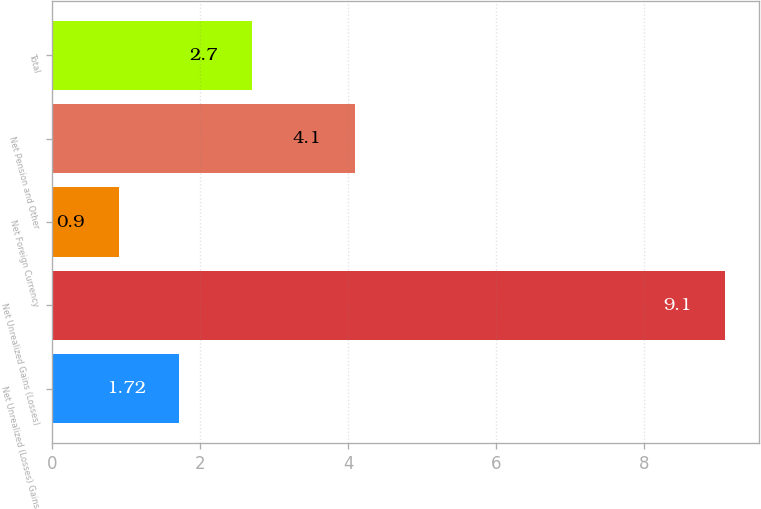<chart> <loc_0><loc_0><loc_500><loc_500><bar_chart><fcel>Net Unrealized (Losses) Gains<fcel>Net Unrealized Gains (Losses)<fcel>Net Foreign Currency<fcel>Net Pension and Other<fcel>Total<nl><fcel>1.72<fcel>9.1<fcel>0.9<fcel>4.1<fcel>2.7<nl></chart> 